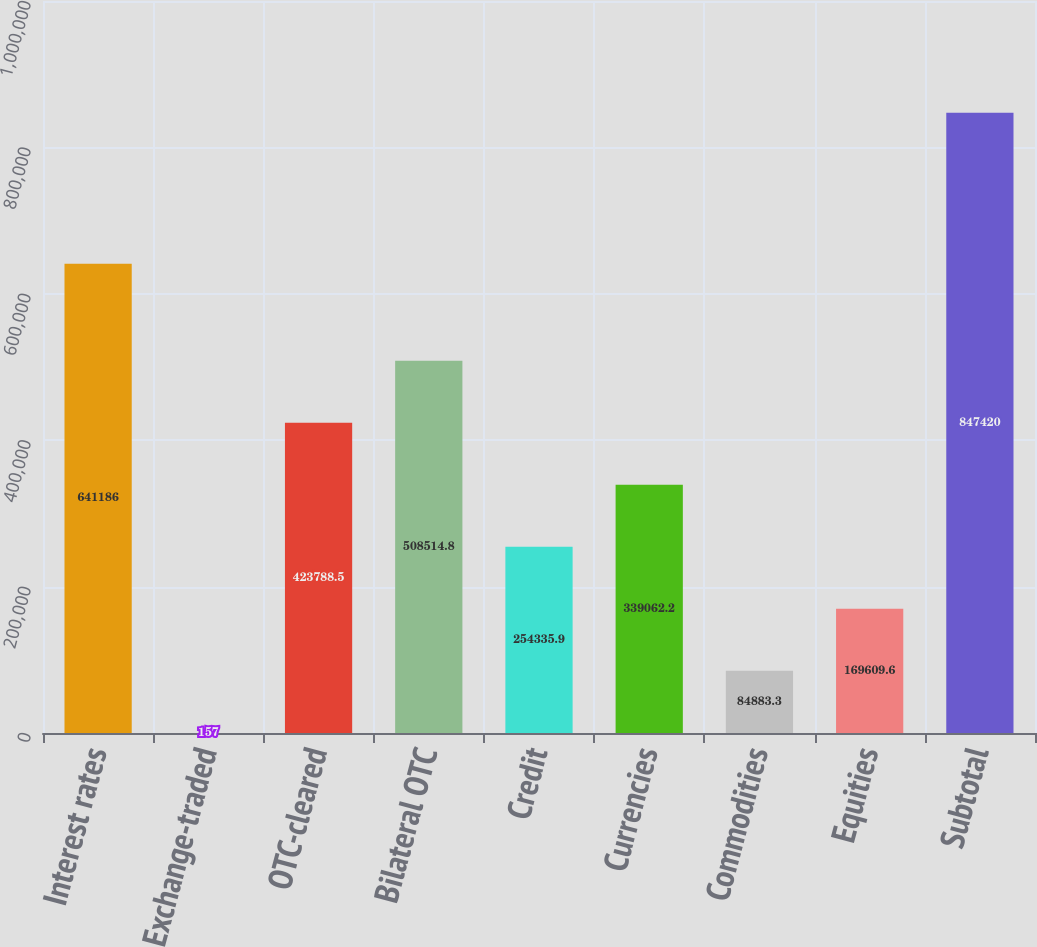Convert chart. <chart><loc_0><loc_0><loc_500><loc_500><bar_chart><fcel>Interest rates<fcel>Exchange-traded<fcel>OTC-cleared<fcel>Bilateral OTC<fcel>Credit<fcel>Currencies<fcel>Commodities<fcel>Equities<fcel>Subtotal<nl><fcel>641186<fcel>157<fcel>423788<fcel>508515<fcel>254336<fcel>339062<fcel>84883.3<fcel>169610<fcel>847420<nl></chart> 